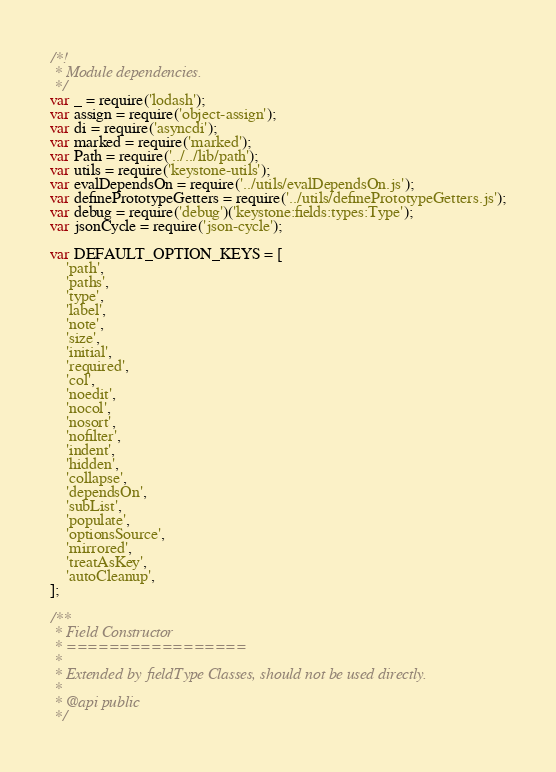Convert code to text. <code><loc_0><loc_0><loc_500><loc_500><_JavaScript_>/*!
 * Module dependencies.
 */
var _ = require('lodash');
var assign = require('object-assign');
var di = require('asyncdi');
var marked = require('marked');
var Path = require('../../lib/path');
var utils = require('keystone-utils');
var evalDependsOn = require('../utils/evalDependsOn.js');
var definePrototypeGetters = require('../utils/definePrototypeGetters.js');
var debug = require('debug')('keystone:fields:types:Type');
var jsonCycle = require('json-cycle');

var DEFAULT_OPTION_KEYS = [
	'path',
	'paths',
	'type',
	'label',
	'note',
	'size',
	'initial',
	'required',
	'col',
	'noedit',
	'nocol',
	'nosort',
	'nofilter',
	'indent',
	'hidden',
	'collapse',
	'dependsOn',
	'subList',
	'populate',
	'optionsSource',
	'mirrored',
	'treatAsKey',
	'autoCleanup',
];

/**
 * Field Constructor
 * =================
 *
 * Extended by fieldType Classes, should not be used directly.
 *
 * @api public
 */</code> 